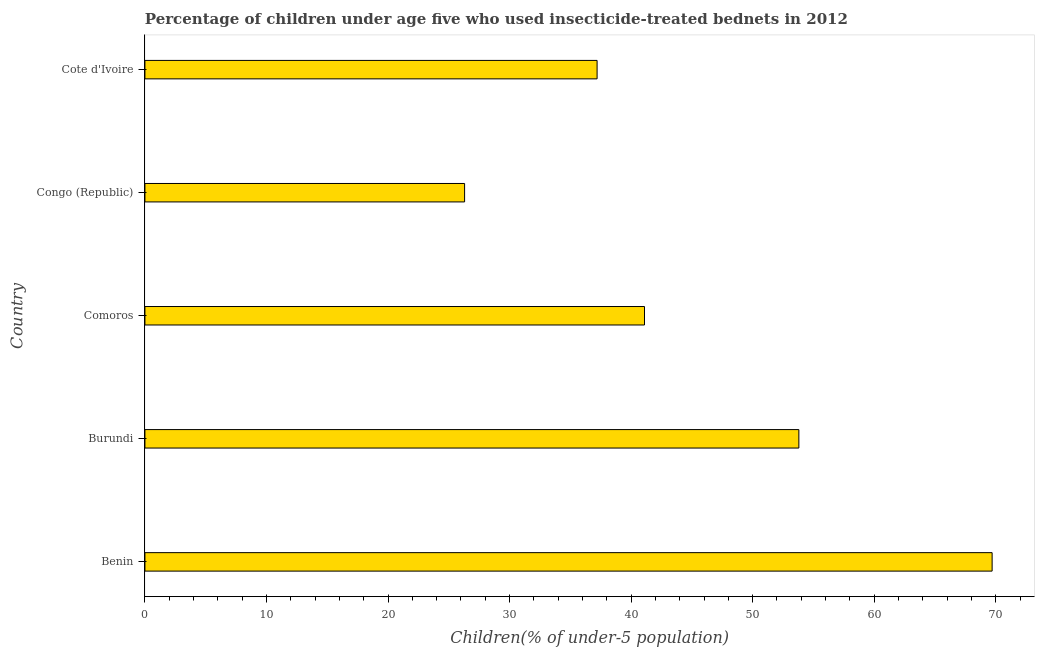Does the graph contain any zero values?
Make the answer very short. No. What is the title of the graph?
Offer a very short reply. Percentage of children under age five who used insecticide-treated bednets in 2012. What is the label or title of the X-axis?
Give a very brief answer. Children(% of under-5 population). What is the label or title of the Y-axis?
Provide a short and direct response. Country. What is the percentage of children who use of insecticide-treated bed nets in Comoros?
Give a very brief answer. 41.1. Across all countries, what is the maximum percentage of children who use of insecticide-treated bed nets?
Your answer should be compact. 69.7. Across all countries, what is the minimum percentage of children who use of insecticide-treated bed nets?
Ensure brevity in your answer.  26.3. In which country was the percentage of children who use of insecticide-treated bed nets maximum?
Your answer should be very brief. Benin. In which country was the percentage of children who use of insecticide-treated bed nets minimum?
Make the answer very short. Congo (Republic). What is the sum of the percentage of children who use of insecticide-treated bed nets?
Your answer should be very brief. 228.1. What is the difference between the percentage of children who use of insecticide-treated bed nets in Benin and Comoros?
Provide a short and direct response. 28.6. What is the average percentage of children who use of insecticide-treated bed nets per country?
Give a very brief answer. 45.62. What is the median percentage of children who use of insecticide-treated bed nets?
Keep it short and to the point. 41.1. What is the ratio of the percentage of children who use of insecticide-treated bed nets in Benin to that in Congo (Republic)?
Provide a short and direct response. 2.65. Is the percentage of children who use of insecticide-treated bed nets in Benin less than that in Burundi?
Your answer should be very brief. No. What is the difference between the highest and the second highest percentage of children who use of insecticide-treated bed nets?
Make the answer very short. 15.9. What is the difference between the highest and the lowest percentage of children who use of insecticide-treated bed nets?
Your answer should be compact. 43.4. Are all the bars in the graph horizontal?
Your answer should be very brief. Yes. How many countries are there in the graph?
Your answer should be very brief. 5. What is the difference between two consecutive major ticks on the X-axis?
Your answer should be very brief. 10. Are the values on the major ticks of X-axis written in scientific E-notation?
Your response must be concise. No. What is the Children(% of under-5 population) in Benin?
Your answer should be compact. 69.7. What is the Children(% of under-5 population) in Burundi?
Offer a very short reply. 53.8. What is the Children(% of under-5 population) in Comoros?
Keep it short and to the point. 41.1. What is the Children(% of under-5 population) of Congo (Republic)?
Provide a short and direct response. 26.3. What is the Children(% of under-5 population) of Cote d'Ivoire?
Ensure brevity in your answer.  37.2. What is the difference between the Children(% of under-5 population) in Benin and Burundi?
Keep it short and to the point. 15.9. What is the difference between the Children(% of under-5 population) in Benin and Comoros?
Provide a succinct answer. 28.6. What is the difference between the Children(% of under-5 population) in Benin and Congo (Republic)?
Your answer should be compact. 43.4. What is the difference between the Children(% of under-5 population) in Benin and Cote d'Ivoire?
Make the answer very short. 32.5. What is the difference between the Children(% of under-5 population) in Burundi and Congo (Republic)?
Provide a short and direct response. 27.5. What is the difference between the Children(% of under-5 population) in Burundi and Cote d'Ivoire?
Make the answer very short. 16.6. What is the difference between the Children(% of under-5 population) in Comoros and Cote d'Ivoire?
Provide a short and direct response. 3.9. What is the difference between the Children(% of under-5 population) in Congo (Republic) and Cote d'Ivoire?
Provide a short and direct response. -10.9. What is the ratio of the Children(% of under-5 population) in Benin to that in Burundi?
Your answer should be very brief. 1.3. What is the ratio of the Children(% of under-5 population) in Benin to that in Comoros?
Offer a very short reply. 1.7. What is the ratio of the Children(% of under-5 population) in Benin to that in Congo (Republic)?
Give a very brief answer. 2.65. What is the ratio of the Children(% of under-5 population) in Benin to that in Cote d'Ivoire?
Give a very brief answer. 1.87. What is the ratio of the Children(% of under-5 population) in Burundi to that in Comoros?
Offer a terse response. 1.31. What is the ratio of the Children(% of under-5 population) in Burundi to that in Congo (Republic)?
Your response must be concise. 2.05. What is the ratio of the Children(% of under-5 population) in Burundi to that in Cote d'Ivoire?
Ensure brevity in your answer.  1.45. What is the ratio of the Children(% of under-5 population) in Comoros to that in Congo (Republic)?
Offer a very short reply. 1.56. What is the ratio of the Children(% of under-5 population) in Comoros to that in Cote d'Ivoire?
Provide a short and direct response. 1.1. What is the ratio of the Children(% of under-5 population) in Congo (Republic) to that in Cote d'Ivoire?
Your response must be concise. 0.71. 